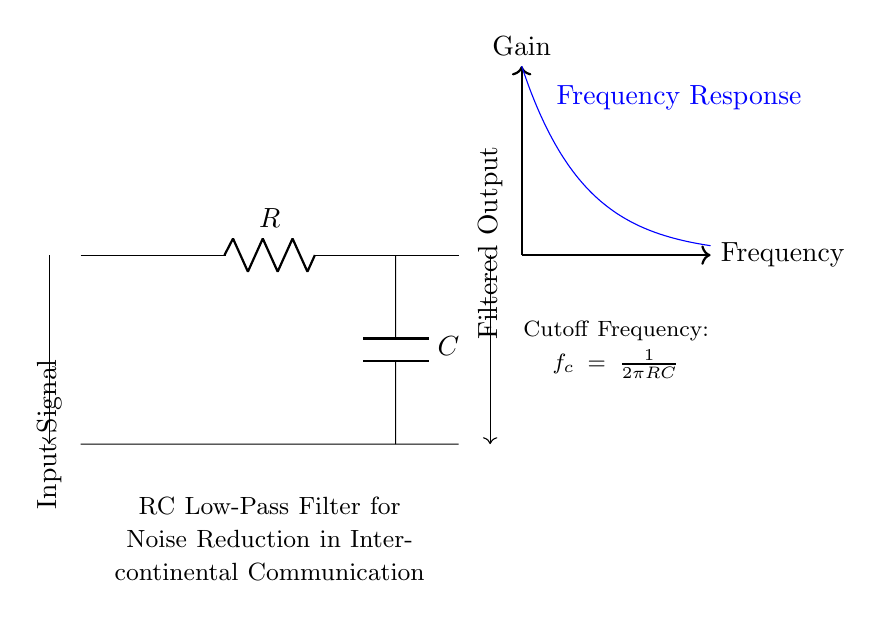What type of filter is shown in the diagram? The diagram illustrates an RC Low-Pass Filter, which is specifically designed to allow low-frequency signals to pass while attenuating higher-frequency signals. This is evidenced by the components depicted and the labeling within the diagram.
Answer: RC Low-Pass Filter What are the components of the circuit? The circuit consists of a resistor (R) and a capacitor (C), which is evident from the labeled symbols in the diagram. These two components are fundamental for creating an RC low-pass filter.
Answer: Resistor and Capacitor What does the frequency response graph represent? The frequency response graph illustrates how gain changes with frequency, showing that gain decreases as frequency increases. This is indicated by the plotted curve in blue, which visualizes the relationship between gain and frequency for the filter.
Answer: Gain vs. Frequency What is the cutoff frequency formula indicated in the diagram? The formula for cutoff frequency shown in the diagram is f_c = 1/(2πRC). This formula defines the point where the output signal starts to attenuate significantly, marking the transition between passband and stopband.
Answer: f_c = 1/(2πRC) How can you determine the effect of the RC values on cutoff frequency? The cutoff frequency is inversely proportional to the product of the resistor value (R) and capacitor value (C). Larger values of R or C will result in a lower cutoff frequency, while smaller values will increase the cutoff frequency. This relationship is derived from the cutoff frequency formula noted in the circuit.
Answer: Larger R or C lowers cutoff frequency What happens to a high-frequency input signal when it passes through this filter? A high-frequency input signal is significantly attenuated when passing through this RC Low-Pass Filter, which is the intended function of this circuit design. The filter allows low frequencies to pass while reducing the amplitude of higher frequencies, resulting in a cleaner output signal.
Answer: Attenuated 